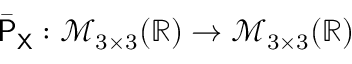<formula> <loc_0><loc_0><loc_500><loc_500>\bar { P } _ { X } \colon \mathcal { M } _ { 3 \times 3 } ( \mathbb { R } ) \to \mathcal { M } _ { 3 \times 3 } ( \mathbb { R } )</formula> 